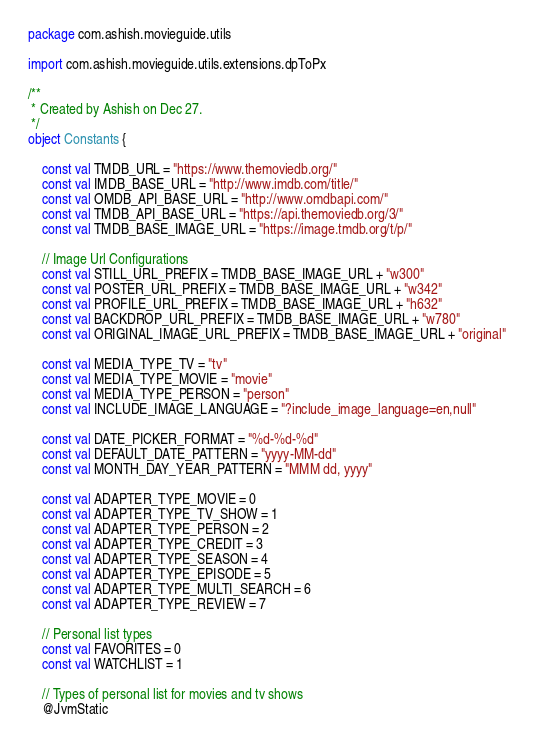Convert code to text. <code><loc_0><loc_0><loc_500><loc_500><_Kotlin_>package com.ashish.movieguide.utils

import com.ashish.movieguide.utils.extensions.dpToPx

/**
 * Created by Ashish on Dec 27.
 */
object Constants {

    const val TMDB_URL = "https://www.themoviedb.org/"
    const val IMDB_BASE_URL = "http://www.imdb.com/title/"
    const val OMDB_API_BASE_URL = "http://www.omdbapi.com/"
    const val TMDB_API_BASE_URL = "https://api.themoviedb.org/3/"
    const val TMDB_BASE_IMAGE_URL = "https://image.tmdb.org/t/p/"

    // Image Url Configurations
    const val STILL_URL_PREFIX = TMDB_BASE_IMAGE_URL + "w300"
    const val POSTER_URL_PREFIX = TMDB_BASE_IMAGE_URL + "w342"
    const val PROFILE_URL_PREFIX = TMDB_BASE_IMAGE_URL + "h632"
    const val BACKDROP_URL_PREFIX = TMDB_BASE_IMAGE_URL + "w780"
    const val ORIGINAL_IMAGE_URL_PREFIX = TMDB_BASE_IMAGE_URL + "original"

    const val MEDIA_TYPE_TV = "tv"
    const val MEDIA_TYPE_MOVIE = "movie"
    const val MEDIA_TYPE_PERSON = "person"
    const val INCLUDE_IMAGE_LANGUAGE = "?include_image_language=en,null"

    const val DATE_PICKER_FORMAT = "%d-%d-%d"
    const val DEFAULT_DATE_PATTERN = "yyyy-MM-dd"
    const val MONTH_DAY_YEAR_PATTERN = "MMM dd, yyyy"

    const val ADAPTER_TYPE_MOVIE = 0
    const val ADAPTER_TYPE_TV_SHOW = 1
    const val ADAPTER_TYPE_PERSON = 2
    const val ADAPTER_TYPE_CREDIT = 3
    const val ADAPTER_TYPE_SEASON = 4
    const val ADAPTER_TYPE_EPISODE = 5
    const val ADAPTER_TYPE_MULTI_SEARCH = 6
    const val ADAPTER_TYPE_REVIEW = 7

    // Personal list types
    const val FAVORITES = 0
    const val WATCHLIST = 1

    // Types of personal list for movies and tv shows
    @JvmStatic</code> 